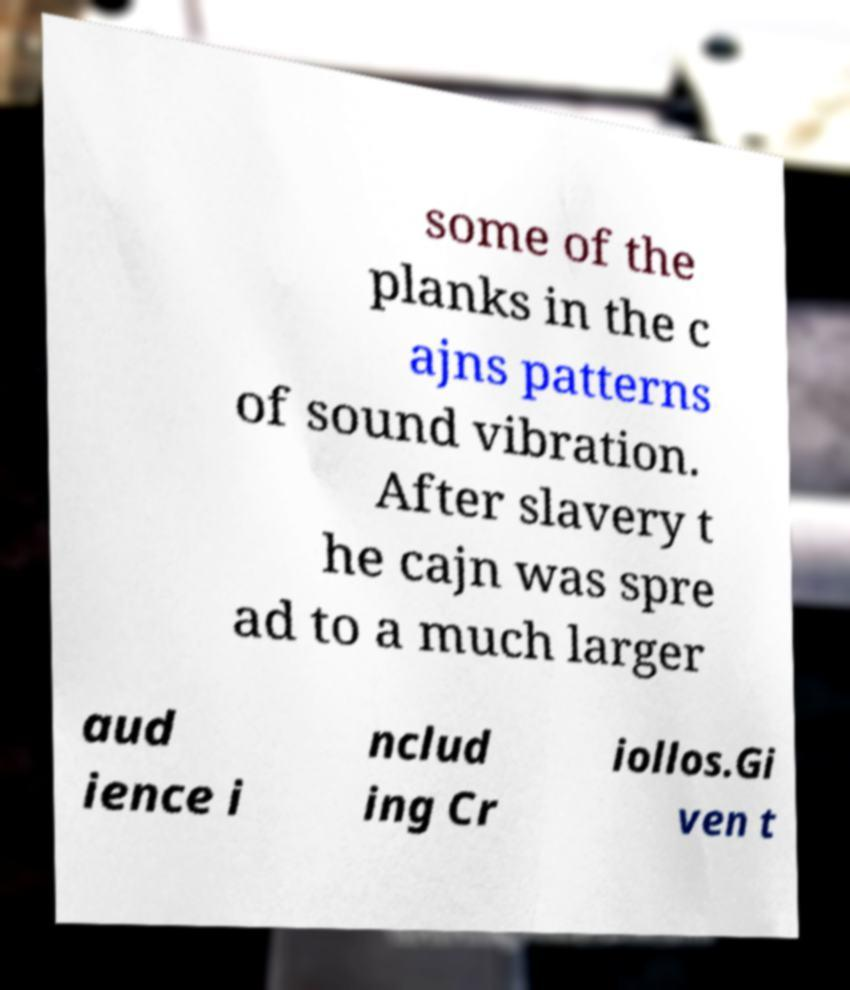Can you read and provide the text displayed in the image?This photo seems to have some interesting text. Can you extract and type it out for me? some of the planks in the c ajns patterns of sound vibration. After slavery t he cajn was spre ad to a much larger aud ience i nclud ing Cr iollos.Gi ven t 